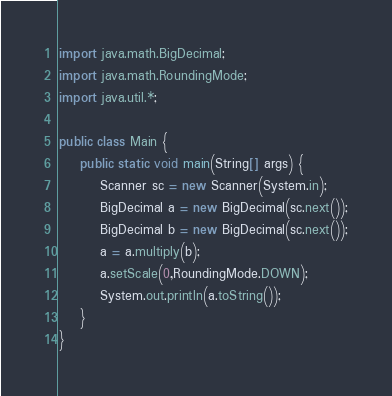<code> <loc_0><loc_0><loc_500><loc_500><_Java_>import java.math.BigDecimal;
import java.math.RoundingMode;
import java.util.*;

public class Main {
    public static void main(String[] args) {
        Scanner sc = new Scanner(System.in);
        BigDecimal a = new BigDecimal(sc.next());
        BigDecimal b = new BigDecimal(sc.next());
        a = a.multiply(b);
        a.setScale(0,RoundingMode.DOWN);
        System.out.println(a.toString());
    }
}</code> 